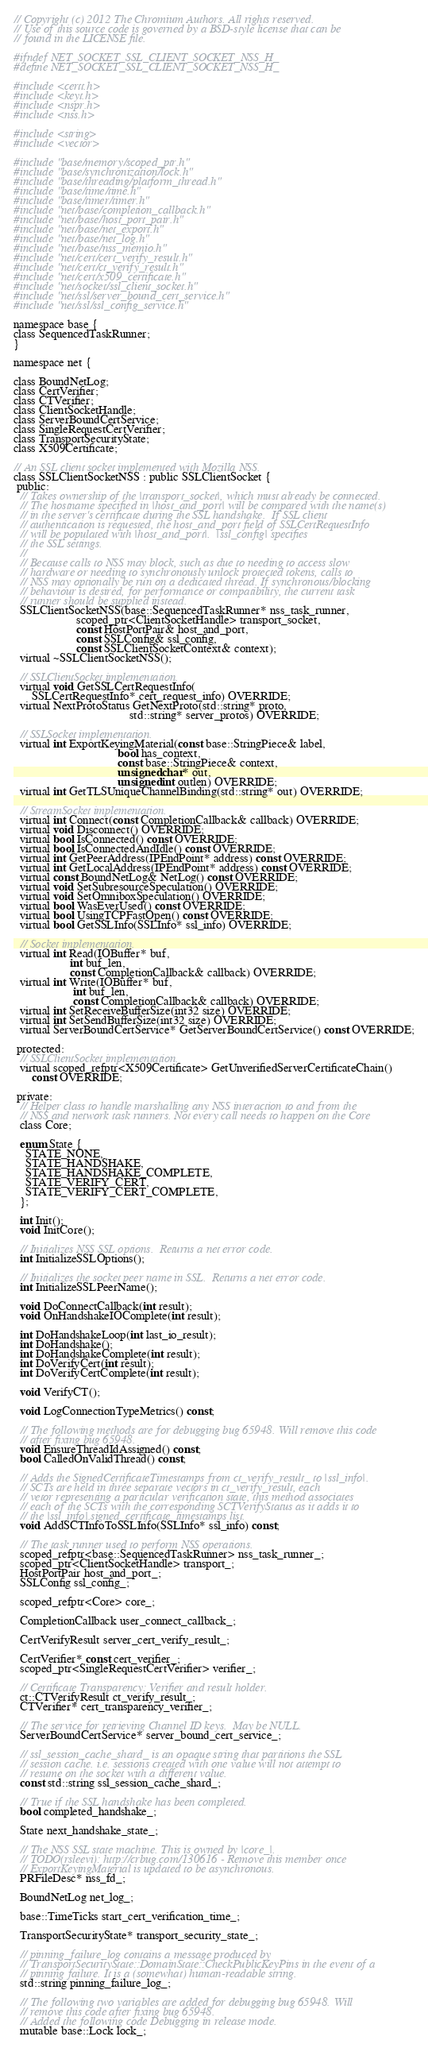Convert code to text. <code><loc_0><loc_0><loc_500><loc_500><_C_>// Copyright (c) 2012 The Chromium Authors. All rights reserved.
// Use of this source code is governed by a BSD-style license that can be
// found in the LICENSE file.

#ifndef NET_SOCKET_SSL_CLIENT_SOCKET_NSS_H_
#define NET_SOCKET_SSL_CLIENT_SOCKET_NSS_H_

#include <certt.h>
#include <keyt.h>
#include <nspr.h>
#include <nss.h>

#include <string>
#include <vector>

#include "base/memory/scoped_ptr.h"
#include "base/synchronization/lock.h"
#include "base/threading/platform_thread.h"
#include "base/time/time.h"
#include "base/timer/timer.h"
#include "net/base/completion_callback.h"
#include "net/base/host_port_pair.h"
#include "net/base/net_export.h"
#include "net/base/net_log.h"
#include "net/base/nss_memio.h"
#include "net/cert/cert_verify_result.h"
#include "net/cert/ct_verify_result.h"
#include "net/cert/x509_certificate.h"
#include "net/socket/ssl_client_socket.h"
#include "net/ssl/server_bound_cert_service.h"
#include "net/ssl/ssl_config_service.h"

namespace base {
class SequencedTaskRunner;
}

namespace net {

class BoundNetLog;
class CertVerifier;
class CTVerifier;
class ClientSocketHandle;
class ServerBoundCertService;
class SingleRequestCertVerifier;
class TransportSecurityState;
class X509Certificate;

// An SSL client socket implemented with Mozilla NSS.
class SSLClientSocketNSS : public SSLClientSocket {
 public:
  // Takes ownership of the |transport_socket|, which must already be connected.
  // The hostname specified in |host_and_port| will be compared with the name(s)
  // in the server's certificate during the SSL handshake.  If SSL client
  // authentication is requested, the host_and_port field of SSLCertRequestInfo
  // will be populated with |host_and_port|.  |ssl_config| specifies
  // the SSL settings.
  //
  // Because calls to NSS may block, such as due to needing to access slow
  // hardware or needing to synchronously unlock protected tokens, calls to
  // NSS may optionally be run on a dedicated thread. If synchronous/blocking
  // behaviour is desired, for performance or compatibility, the current task
  // runner should be supplied instead.
  SSLClientSocketNSS(base::SequencedTaskRunner* nss_task_runner,
                     scoped_ptr<ClientSocketHandle> transport_socket,
                     const HostPortPair& host_and_port,
                     const SSLConfig& ssl_config,
                     const SSLClientSocketContext& context);
  virtual ~SSLClientSocketNSS();

  // SSLClientSocket implementation.
  virtual void GetSSLCertRequestInfo(
      SSLCertRequestInfo* cert_request_info) OVERRIDE;
  virtual NextProtoStatus GetNextProto(std::string* proto,
                                       std::string* server_protos) OVERRIDE;

  // SSLSocket implementation.
  virtual int ExportKeyingMaterial(const base::StringPiece& label,
                                   bool has_context,
                                   const base::StringPiece& context,
                                   unsigned char* out,
                                   unsigned int outlen) OVERRIDE;
  virtual int GetTLSUniqueChannelBinding(std::string* out) OVERRIDE;

  // StreamSocket implementation.
  virtual int Connect(const CompletionCallback& callback) OVERRIDE;
  virtual void Disconnect() OVERRIDE;
  virtual bool IsConnected() const OVERRIDE;
  virtual bool IsConnectedAndIdle() const OVERRIDE;
  virtual int GetPeerAddress(IPEndPoint* address) const OVERRIDE;
  virtual int GetLocalAddress(IPEndPoint* address) const OVERRIDE;
  virtual const BoundNetLog& NetLog() const OVERRIDE;
  virtual void SetSubresourceSpeculation() OVERRIDE;
  virtual void SetOmniboxSpeculation() OVERRIDE;
  virtual bool WasEverUsed() const OVERRIDE;
  virtual bool UsingTCPFastOpen() const OVERRIDE;
  virtual bool GetSSLInfo(SSLInfo* ssl_info) OVERRIDE;

  // Socket implementation.
  virtual int Read(IOBuffer* buf,
                   int buf_len,
                   const CompletionCallback& callback) OVERRIDE;
  virtual int Write(IOBuffer* buf,
                    int buf_len,
                    const CompletionCallback& callback) OVERRIDE;
  virtual int SetReceiveBufferSize(int32 size) OVERRIDE;
  virtual int SetSendBufferSize(int32 size) OVERRIDE;
  virtual ServerBoundCertService* GetServerBoundCertService() const OVERRIDE;

 protected:
  // SSLClientSocket implementation.
  virtual scoped_refptr<X509Certificate> GetUnverifiedServerCertificateChain()
      const OVERRIDE;

 private:
  // Helper class to handle marshalling any NSS interaction to and from the
  // NSS and network task runners. Not every call needs to happen on the Core
  class Core;

  enum State {
    STATE_NONE,
    STATE_HANDSHAKE,
    STATE_HANDSHAKE_COMPLETE,
    STATE_VERIFY_CERT,
    STATE_VERIFY_CERT_COMPLETE,
  };

  int Init();
  void InitCore();

  // Initializes NSS SSL options.  Returns a net error code.
  int InitializeSSLOptions();

  // Initializes the socket peer name in SSL.  Returns a net error code.
  int InitializeSSLPeerName();

  void DoConnectCallback(int result);
  void OnHandshakeIOComplete(int result);

  int DoHandshakeLoop(int last_io_result);
  int DoHandshake();
  int DoHandshakeComplete(int result);
  int DoVerifyCert(int result);
  int DoVerifyCertComplete(int result);

  void VerifyCT();

  void LogConnectionTypeMetrics() const;

  // The following methods are for debugging bug 65948. Will remove this code
  // after fixing bug 65948.
  void EnsureThreadIdAssigned() const;
  bool CalledOnValidThread() const;

  // Adds the SignedCertificateTimestamps from ct_verify_result_ to |ssl_info|.
  // SCTs are held in three separate vectors in ct_verify_result, each
  // vetor representing a particular verification state, this method associates
  // each of the SCTs with the corresponding SCTVerifyStatus as it adds it to
  // the |ssl_info|.signed_certificate_timestamps list.
  void AddSCTInfoToSSLInfo(SSLInfo* ssl_info) const;

  // The task runner used to perform NSS operations.
  scoped_refptr<base::SequencedTaskRunner> nss_task_runner_;
  scoped_ptr<ClientSocketHandle> transport_;
  HostPortPair host_and_port_;
  SSLConfig ssl_config_;

  scoped_refptr<Core> core_;

  CompletionCallback user_connect_callback_;

  CertVerifyResult server_cert_verify_result_;

  CertVerifier* const cert_verifier_;
  scoped_ptr<SingleRequestCertVerifier> verifier_;

  // Certificate Transparency: Verifier and result holder.
  ct::CTVerifyResult ct_verify_result_;
  CTVerifier* cert_transparency_verifier_;

  // The service for retrieving Channel ID keys.  May be NULL.
  ServerBoundCertService* server_bound_cert_service_;

  // ssl_session_cache_shard_ is an opaque string that partitions the SSL
  // session cache. i.e. sessions created with one value will not attempt to
  // resume on the socket with a different value.
  const std::string ssl_session_cache_shard_;

  // True if the SSL handshake has been completed.
  bool completed_handshake_;

  State next_handshake_state_;

  // The NSS SSL state machine. This is owned by |core_|.
  // TODO(rsleevi): http://crbug.com/130616 - Remove this member once
  // ExportKeyingMaterial is updated to be asynchronous.
  PRFileDesc* nss_fd_;

  BoundNetLog net_log_;

  base::TimeTicks start_cert_verification_time_;

  TransportSecurityState* transport_security_state_;

  // pinning_failure_log contains a message produced by
  // TransportSecurityState::DomainState::CheckPublicKeyPins in the event of a
  // pinning failure. It is a (somewhat) human-readable string.
  std::string pinning_failure_log_;

  // The following two variables are added for debugging bug 65948. Will
  // remove this code after fixing bug 65948.
  // Added the following code Debugging in release mode.
  mutable base::Lock lock_;</code> 